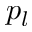<formula> <loc_0><loc_0><loc_500><loc_500>p _ { l }</formula> 